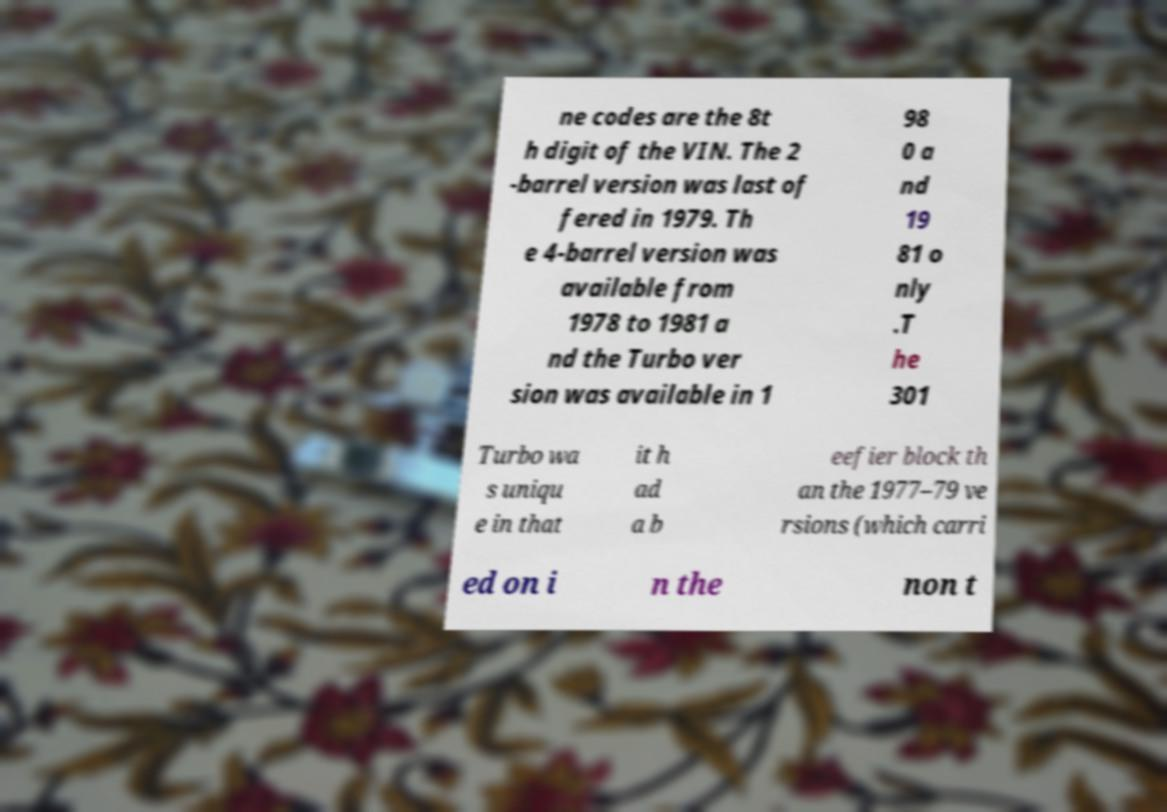Can you accurately transcribe the text from the provided image for me? ne codes are the 8t h digit of the VIN. The 2 -barrel version was last of fered in 1979. Th e 4-barrel version was available from 1978 to 1981 a nd the Turbo ver sion was available in 1 98 0 a nd 19 81 o nly .T he 301 Turbo wa s uniqu e in that it h ad a b eefier block th an the 1977–79 ve rsions (which carri ed on i n the non t 